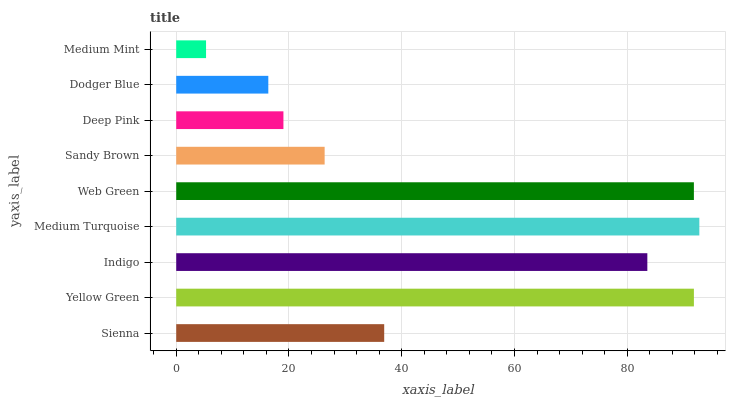Is Medium Mint the minimum?
Answer yes or no. Yes. Is Medium Turquoise the maximum?
Answer yes or no. Yes. Is Yellow Green the minimum?
Answer yes or no. No. Is Yellow Green the maximum?
Answer yes or no. No. Is Yellow Green greater than Sienna?
Answer yes or no. Yes. Is Sienna less than Yellow Green?
Answer yes or no. Yes. Is Sienna greater than Yellow Green?
Answer yes or no. No. Is Yellow Green less than Sienna?
Answer yes or no. No. Is Sienna the high median?
Answer yes or no. Yes. Is Sienna the low median?
Answer yes or no. Yes. Is Deep Pink the high median?
Answer yes or no. No. Is Web Green the low median?
Answer yes or no. No. 